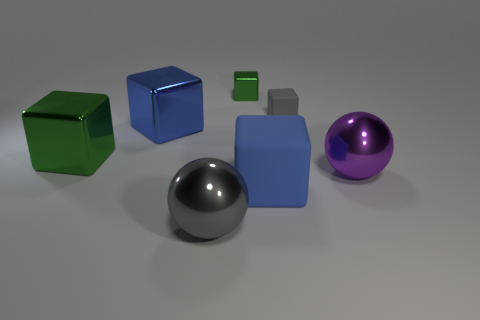Subtract all green blocks. How many blocks are left? 3 Add 1 gray metal balls. How many objects exist? 8 Subtract all blue blocks. How many blocks are left? 3 Subtract all blocks. How many objects are left? 2 Subtract 1 balls. How many balls are left? 1 Subtract all brown cylinders. How many red cubes are left? 0 Add 2 small rubber things. How many small rubber things exist? 3 Subtract 0 brown blocks. How many objects are left? 7 Subtract all red balls. Subtract all red blocks. How many balls are left? 2 Subtract all big spheres. Subtract all blue rubber objects. How many objects are left? 4 